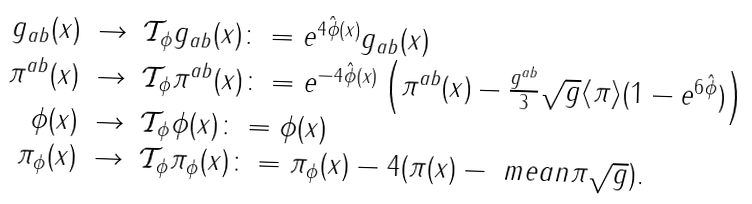<formula> <loc_0><loc_0><loc_500><loc_500>\begin{array} { r c l } g _ { a b } ( x ) & \to & \mathcal { T } _ { \phi } g _ { a b } ( x ) \colon = e ^ { 4 \hat { \phi } ( x ) } g _ { a b } ( x ) \\ \pi ^ { a b } ( x ) & \to & \mathcal { T } _ { \phi } \pi ^ { a b } ( x ) \colon = e ^ { - 4 \hat { \phi } ( x ) } \left ( \pi ^ { a b } ( x ) - \frac { g ^ { a b } } { 3 } \sqrt { g } \langle \pi \rangle ( 1 - e ^ { 6 \hat { \phi } } ) \right ) \\ \phi ( x ) & \to & \mathcal { T } _ { \phi } \phi ( x ) \colon = \phi ( x ) \\ \pi _ { \phi } ( x ) & \to & \mathcal { T } _ { \phi } \pi _ { \phi } ( x ) \colon = \pi _ { \phi } ( x ) - 4 ( \pi ( x ) - \ m e a n { \pi } \sqrt { g } ) . \end{array}</formula> 